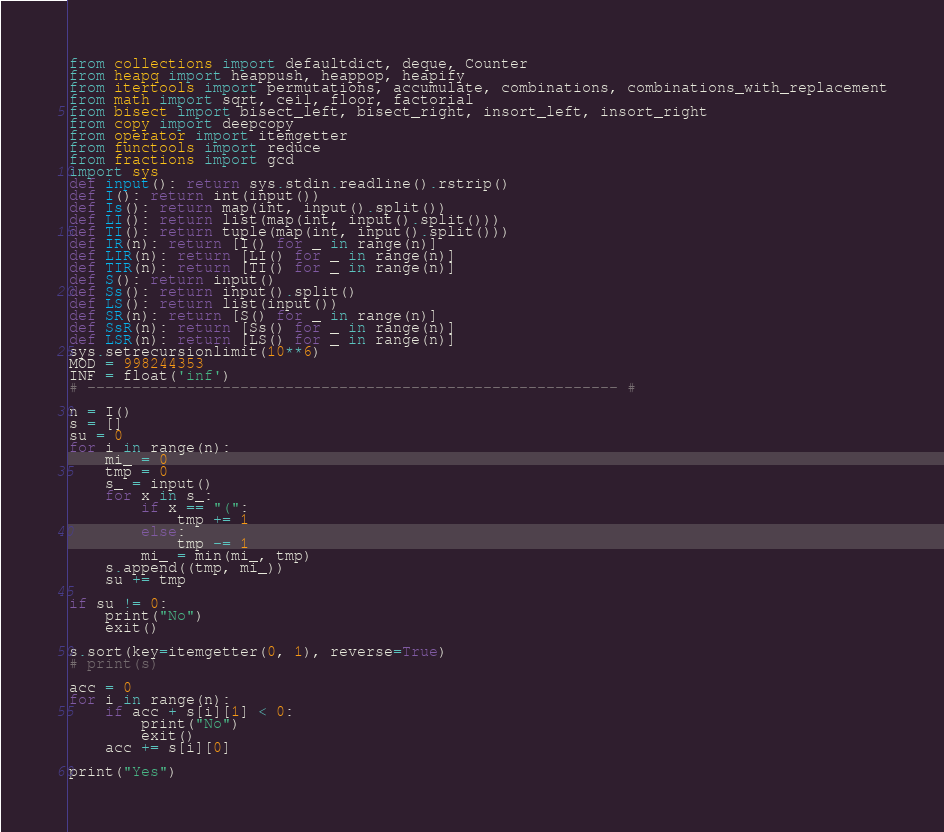Convert code to text. <code><loc_0><loc_0><loc_500><loc_500><_Python_>from collections import defaultdict, deque, Counter
from heapq import heappush, heappop, heapify
from itertools import permutations, accumulate, combinations, combinations_with_replacement
from math import sqrt, ceil, floor, factorial
from bisect import bisect_left, bisect_right, insort_left, insort_right
from copy import deepcopy
from operator import itemgetter
from functools import reduce
from fractions import gcd
import sys
def input(): return sys.stdin.readline().rstrip()
def I(): return int(input())
def Is(): return map(int, input().split())
def LI(): return list(map(int, input().split()))
def TI(): return tuple(map(int, input().split()))
def IR(n): return [I() for _ in range(n)]
def LIR(n): return [LI() for _ in range(n)]
def TIR(n): return [TI() for _ in range(n)]
def S(): return input()
def Ss(): return input().split()
def LS(): return list(input())
def SR(n): return [S() for _ in range(n)]
def SsR(n): return [Ss() for _ in range(n)]
def LSR(n): return [LS() for _ in range(n)]
sys.setrecursionlimit(10**6)
MOD = 998244353
INF = float('inf')
# ----------------------------------------------------------- #

n = I()
s = []
su = 0
for i in range(n):
    mi_ = 0
    tmp = 0
    s_ = input()
    for x in s_:
        if x == "(":
            tmp += 1
        else:
            tmp -= 1
        mi_ = min(mi_, tmp)
    s.append((tmp, mi_))
    su += tmp

if su != 0:
    print("No")
    exit()

s.sort(key=itemgetter(0, 1), reverse=True)
# print(s)

acc = 0
for i in range(n):
    if acc + s[i][1] < 0:
        print("No")
        exit()
    acc += s[i][0]

print("Yes")
</code> 